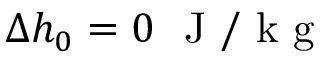Convert formula to latex. <formula><loc_0><loc_0><loc_500><loc_500>\Delta h _ { 0 } = 0 J / k g</formula> 